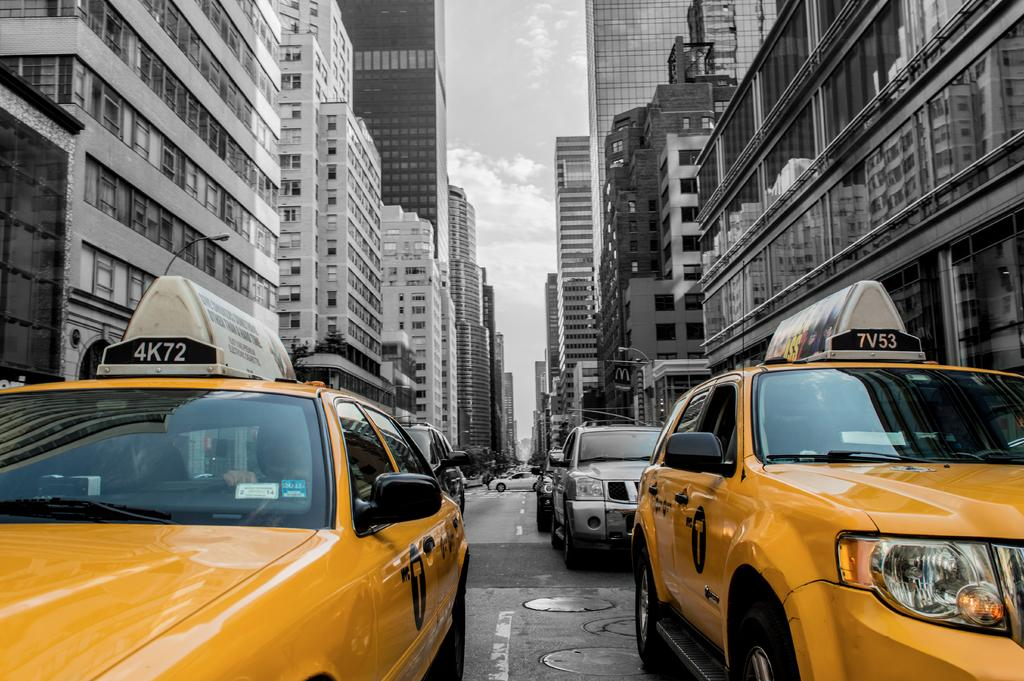<image>
Render a clear and concise summary of the photo. The taxi on the right is identified by 7V53 on the car. 